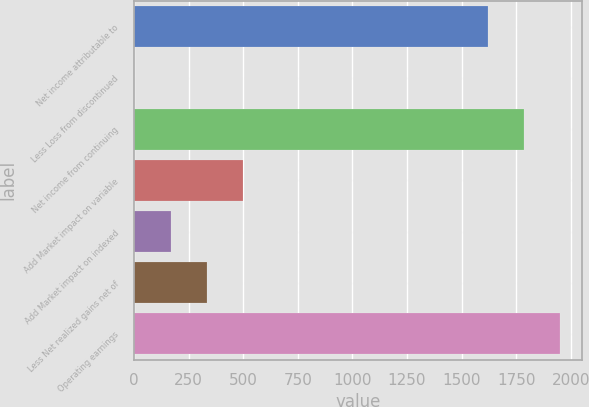Convert chart to OTSL. <chart><loc_0><loc_0><loc_500><loc_500><bar_chart><fcel>Net income attributable to<fcel>Less Loss from discontinued<fcel>Net income from continuing<fcel>Add Market impact on variable<fcel>Add Market impact on indexed<fcel>Less Net realized gains net of<fcel>Operating earnings<nl><fcel>1619<fcel>2<fcel>1785<fcel>500<fcel>168<fcel>334<fcel>1951<nl></chart> 